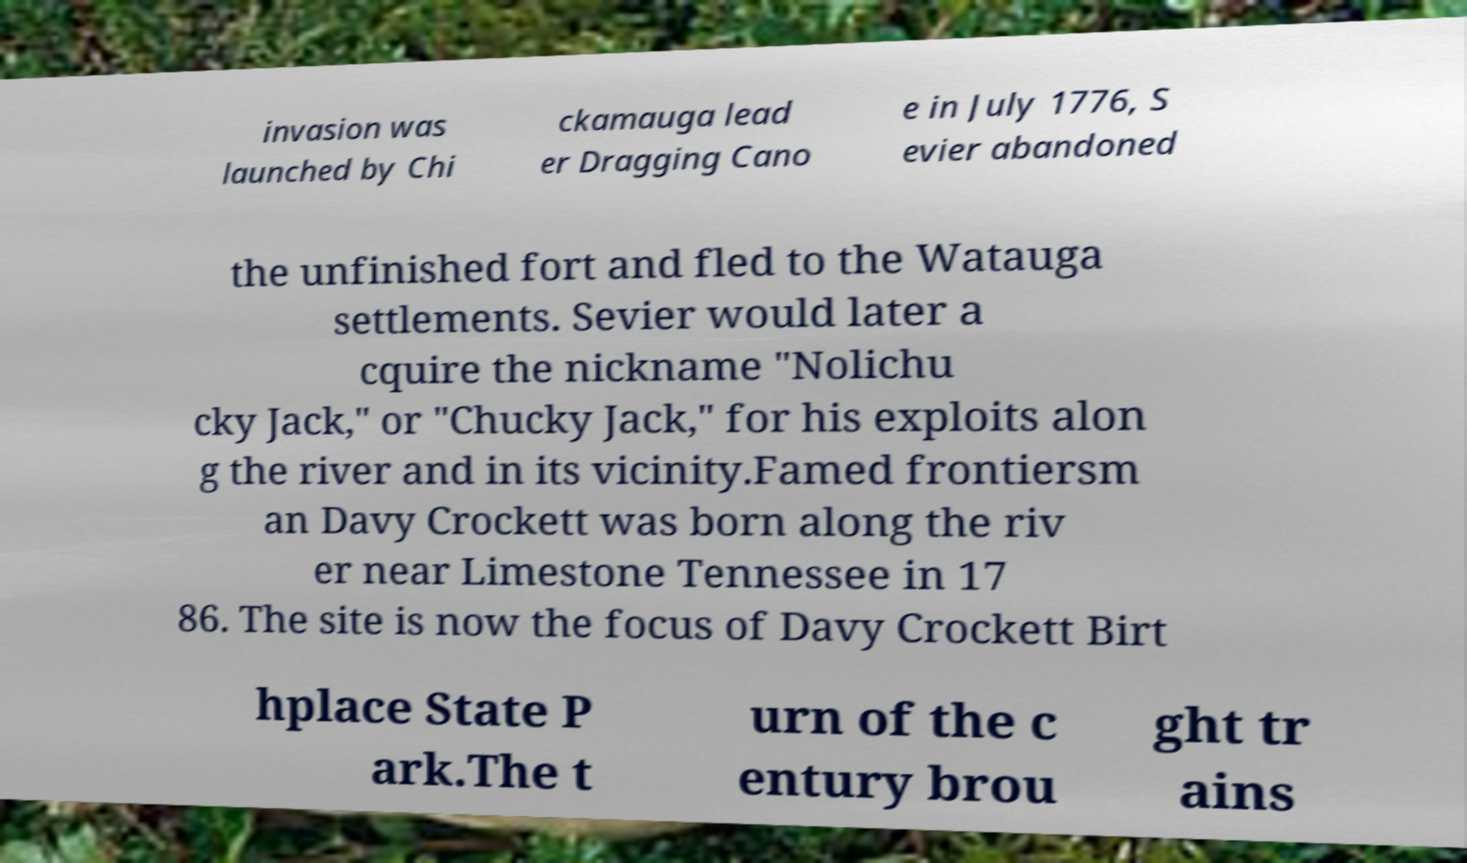Could you extract and type out the text from this image? invasion was launched by Chi ckamauga lead er Dragging Cano e in July 1776, S evier abandoned the unfinished fort and fled to the Watauga settlements. Sevier would later a cquire the nickname "Nolichu cky Jack," or "Chucky Jack," for his exploits alon g the river and in its vicinity.Famed frontiersm an Davy Crockett was born along the riv er near Limestone Tennessee in 17 86. The site is now the focus of Davy Crockett Birt hplace State P ark.The t urn of the c entury brou ght tr ains 